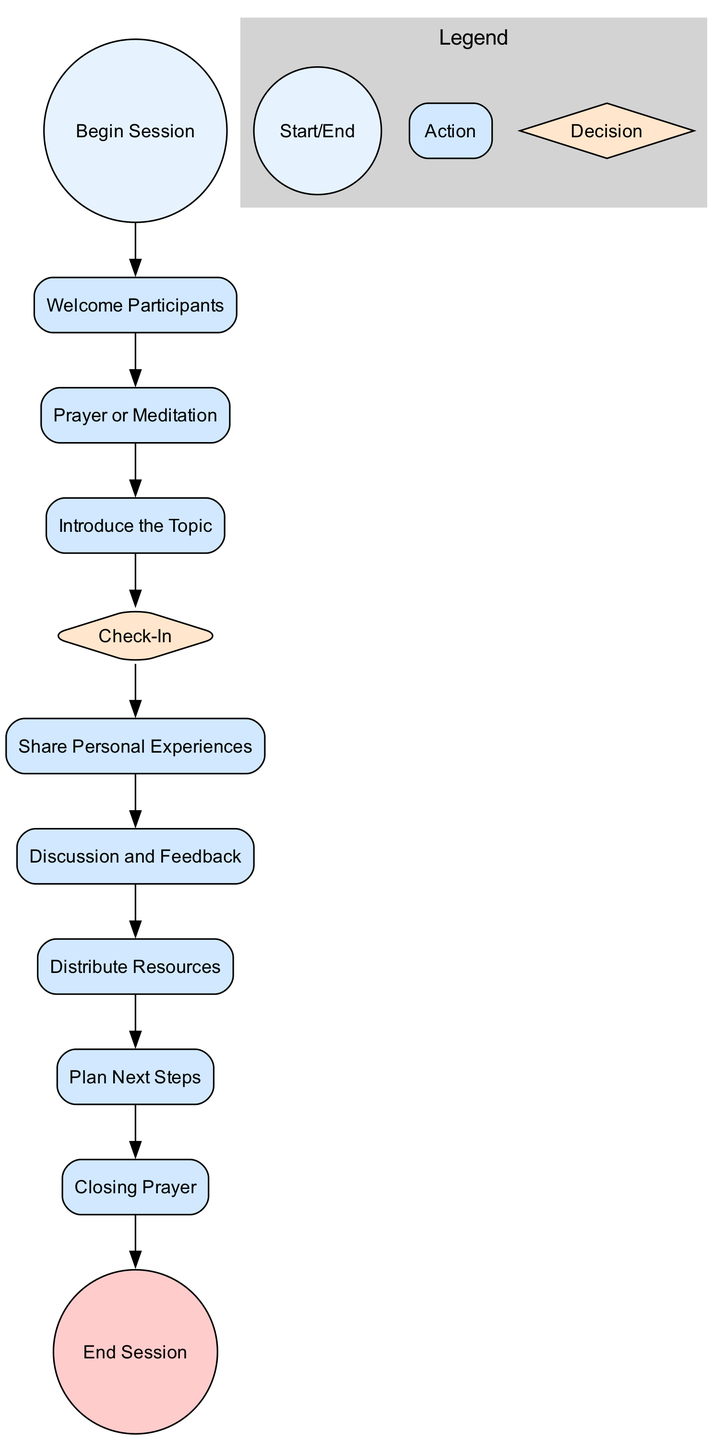What is the first action in the session? The first action in the session as labeled in the diagram is "Welcome Participants." This is the immediate next step after "Begin Session," establishing the initial interaction with group members.
Answer: Welcome Participants How many actions are depicted in this diagram? By counting the elements labeled as "Action," we find there are six actions: "Welcome Participants," "Prayer or Meditation," "Share Personal Experiences," "Discussion and Feedback," "Distribute Resources," and "Plan Next Steps."
Answer: 6 What is the label of the last step before ending the session? The last action before the session ends is "Closing Prayer," which occurs just before the "End Session." This step provides a concluding element of support and reflection.
Answer: Closing Prayer Which node represents a decision point in the diagram? The node labeled "Check-In" is the decision point, indicated by the diamond shape. It prompts participants to decide if they want to share their experiences.
Answer: Check-In What is the purpose of the "Discussion and Feedback" action? This action serves to facilitate open discussion among group members about the topic, allowing them to receive advice and support. It is part of the interactive process essential for recovery.
Answer: Facilitate open discussion What action follows the "Prayer or Meditation"? The action that follows "Prayer or Meditation" is "Introduce the Topic," where the focus of the session is clarified for the participants. This sequence is key to guiding the meeting's direction.
Answer: Introduce the Topic How many total nodes are there in the diagram? By adding the start node, action nodes, decision node, and end node, we find there are a total of eleven nodes in the diagram.
Answer: 11 What is the final event that concludes the session? The final event in the diagram is labeled "End Session," marking the formal conclusion of the support group meeting. This signifies that the session has reached its end.
Answer: End Session 